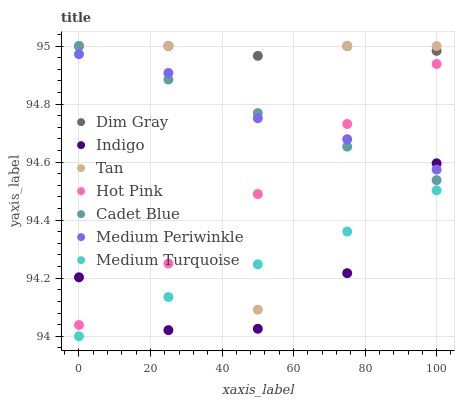Does Indigo have the minimum area under the curve?
Answer yes or no. Yes. Does Dim Gray have the maximum area under the curve?
Answer yes or no. Yes. Does Hot Pink have the minimum area under the curve?
Answer yes or no. No. Does Hot Pink have the maximum area under the curve?
Answer yes or no. No. Is Cadet Blue the smoothest?
Answer yes or no. Yes. Is Tan the roughest?
Answer yes or no. Yes. Is Indigo the smoothest?
Answer yes or no. No. Is Indigo the roughest?
Answer yes or no. No. Does Medium Turquoise have the lowest value?
Answer yes or no. Yes. Does Indigo have the lowest value?
Answer yes or no. No. Does Tan have the highest value?
Answer yes or no. Yes. Does Indigo have the highest value?
Answer yes or no. No. Is Medium Periwinkle less than Dim Gray?
Answer yes or no. Yes. Is Dim Gray greater than Hot Pink?
Answer yes or no. Yes. Does Cadet Blue intersect Tan?
Answer yes or no. Yes. Is Cadet Blue less than Tan?
Answer yes or no. No. Is Cadet Blue greater than Tan?
Answer yes or no. No. Does Medium Periwinkle intersect Dim Gray?
Answer yes or no. No. 